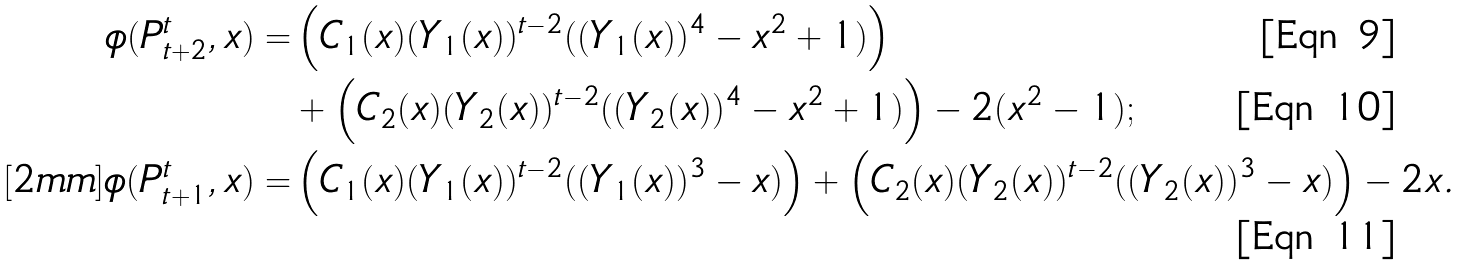Convert formula to latex. <formula><loc_0><loc_0><loc_500><loc_500>\phi ( P _ { t + 2 } ^ { t } , x ) = & \left ( C _ { 1 } ( x ) ( Y _ { 1 } ( x ) ) ^ { t - 2 } ( ( Y _ { 1 } ( x ) ) ^ { 4 } - x ^ { 2 } + 1 ) \right ) \\ & + \left ( C _ { 2 } ( x ) ( Y _ { 2 } ( x ) ) ^ { t - 2 } ( ( Y _ { 2 } ( x ) ) ^ { 4 } - x ^ { 2 } + 1 ) \right ) - 2 ( x ^ { 2 } - 1 ) ; \\ [ 2 m m ] \phi ( P _ { t + 1 } ^ { t } , x ) = & \left ( C _ { 1 } ( x ) ( Y _ { 1 } ( x ) ) ^ { t - 2 } ( ( Y _ { 1 } ( x ) ) ^ { 3 } - x ) \right ) + \left ( C _ { 2 } ( x ) ( Y _ { 2 } ( x ) ) ^ { t - 2 } ( ( Y _ { 2 } ( x ) ) ^ { 3 } - x ) \right ) - 2 x .</formula> 